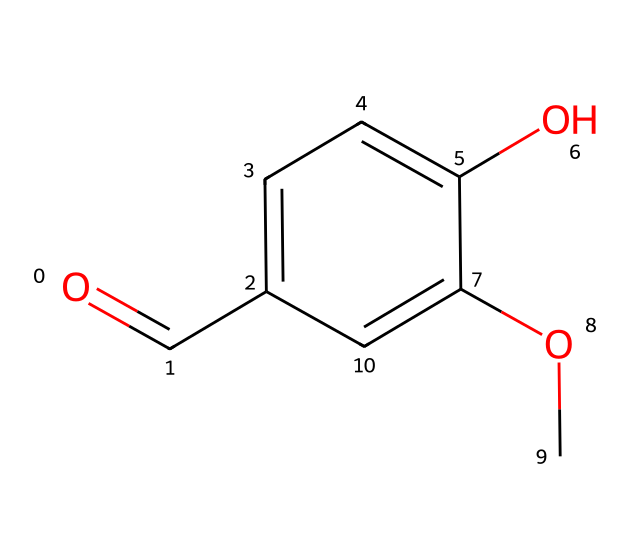What is the main functional group present in vanillin? The main functional group in vanillin can be identified from the structure. The carbonyl (C=O) group, which is characteristic of ketones, is present, indicating its ketone nature.
Answer: carbonyl How many aromatic rings are in the structure of vanillin? Looking at the provided structure, there is one aromatic ring present, which is indicated by the benzene-like six-membered carbon ring.
Answer: one What is the total number of oxygen atoms in vanillin? By examining the structure, there are two oxygen atoms visible: one in the carbonyl group and one in the methoxy (–OCH3) group. Thus, the total is two.
Answer: two Which part of the structure indicates that vanillin is a ketone? In the structure, the presence of the carbonyl group (C=O) indicates that vanillin is a ketone. The location of this carbonyl group in the context of the larger aromatic structure confirms it as a ketone.
Answer: carbonyl group What type of substitution is present on the aromatic ring of vanillin? The structure shows that there is a hydroxyl group (-OH) and a methoxy group (-OCH3) substituted on the aromatic ring. This points to specific substitution patterns on the ring.
Answer: hydroxyl and methoxy 